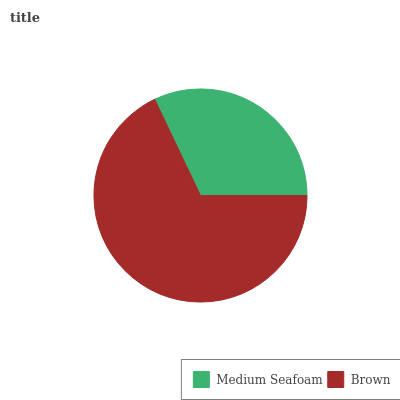Is Medium Seafoam the minimum?
Answer yes or no. Yes. Is Brown the maximum?
Answer yes or no. Yes. Is Brown the minimum?
Answer yes or no. No. Is Brown greater than Medium Seafoam?
Answer yes or no. Yes. Is Medium Seafoam less than Brown?
Answer yes or no. Yes. Is Medium Seafoam greater than Brown?
Answer yes or no. No. Is Brown less than Medium Seafoam?
Answer yes or no. No. Is Brown the high median?
Answer yes or no. Yes. Is Medium Seafoam the low median?
Answer yes or no. Yes. Is Medium Seafoam the high median?
Answer yes or no. No. Is Brown the low median?
Answer yes or no. No. 